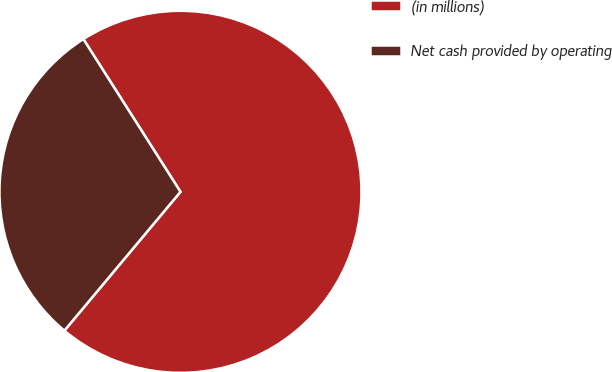<chart> <loc_0><loc_0><loc_500><loc_500><pie_chart><fcel>(in millions)<fcel>Net cash provided by operating<nl><fcel>70.1%<fcel>29.9%<nl></chart> 